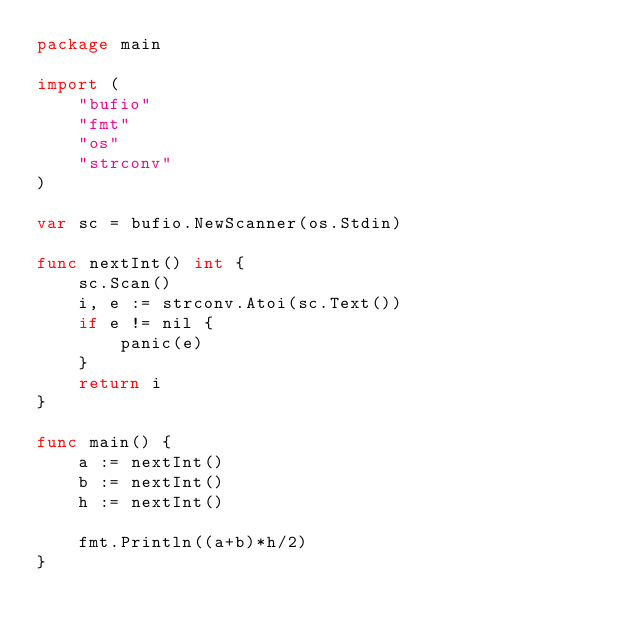Convert code to text. <code><loc_0><loc_0><loc_500><loc_500><_Go_>package main

import (
    "bufio"
    "fmt"
    "os"
    "strconv"
)

var sc = bufio.NewScanner(os.Stdin)

func nextInt() int {
    sc.Scan()
    i, e := strconv.Atoi(sc.Text())
    if e != nil {
        panic(e)
    }
    return i
}

func main() {
    a := nextInt()
    b := nextInt()
    h := nextInt()

    fmt.Println((a+b)*h/2)
}
</code> 